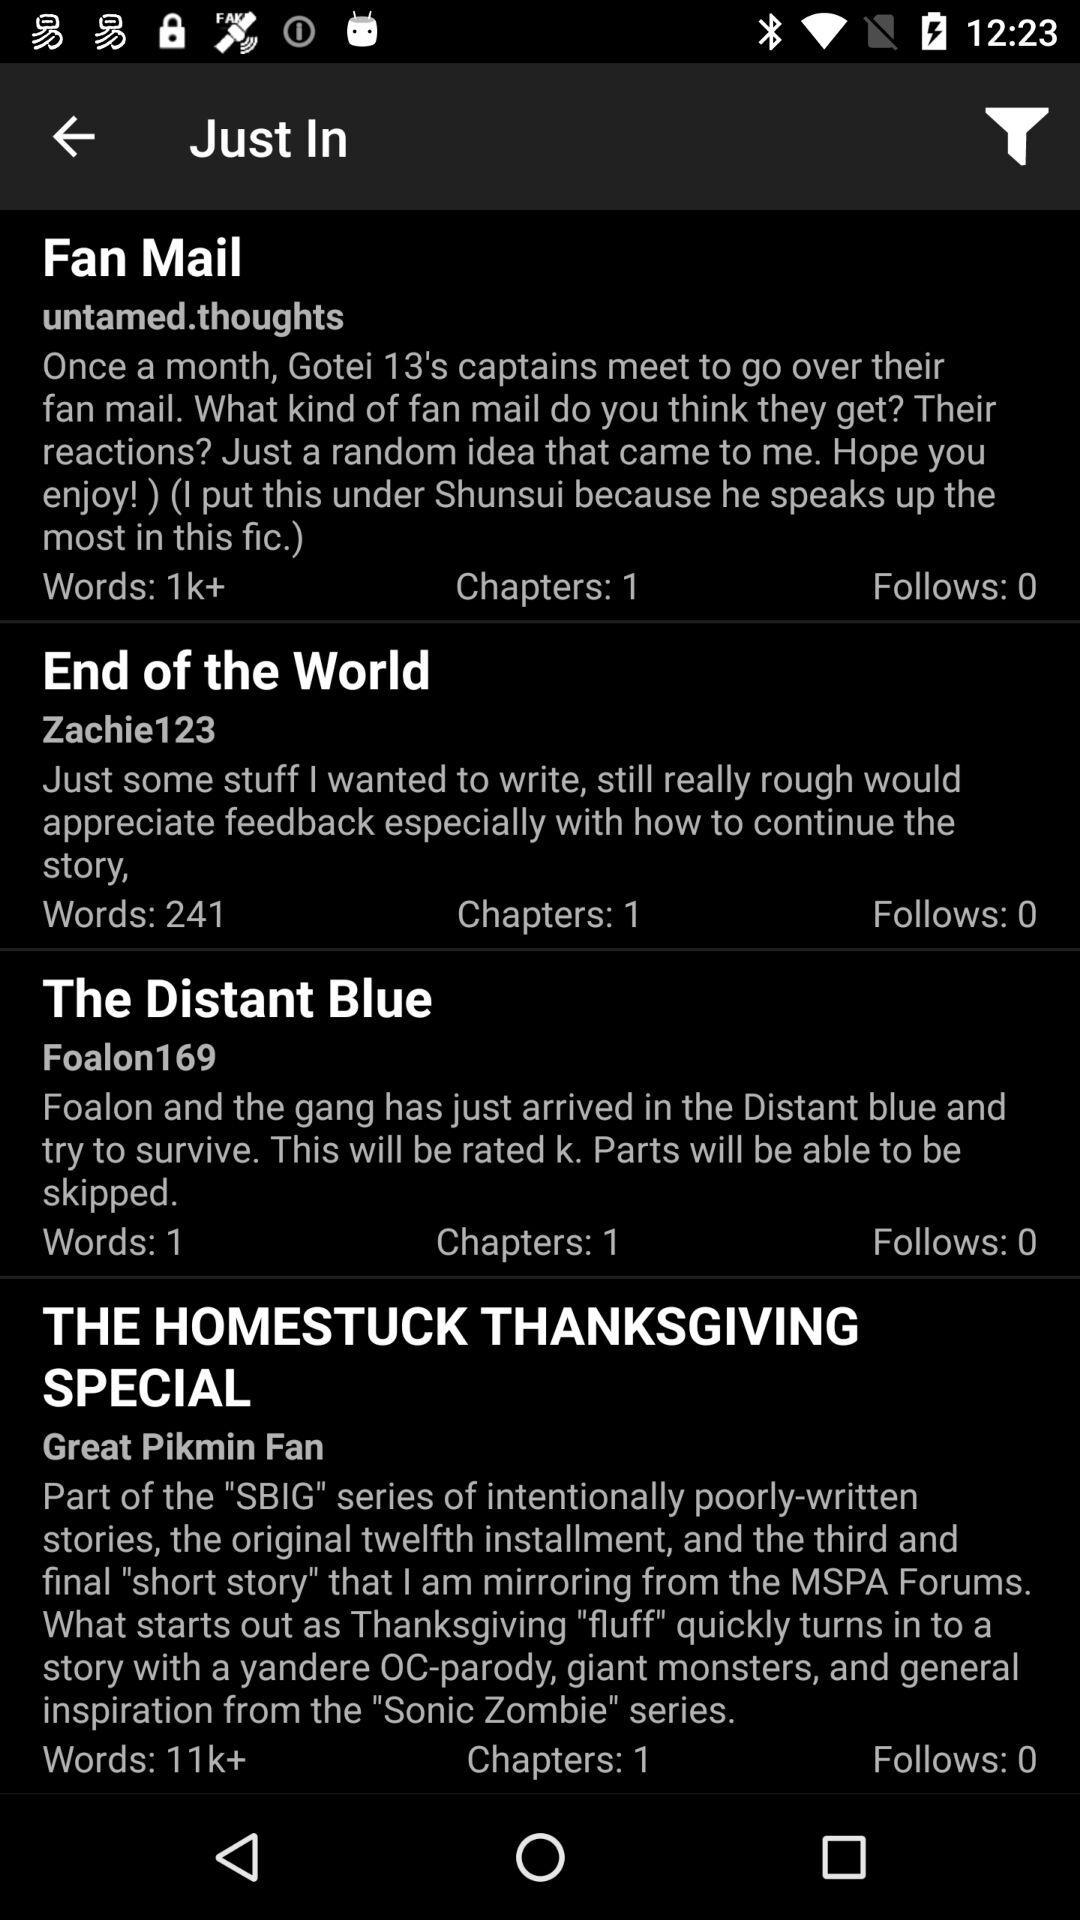Which article was posted by "Foalon169"? The article that was posted by "Foalon169" is "The Distant Blue". 